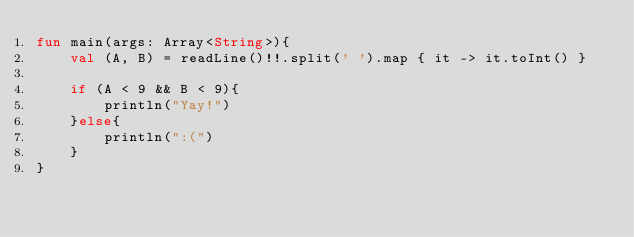Convert code to text. <code><loc_0><loc_0><loc_500><loc_500><_Kotlin_>fun main(args: Array<String>){
    val (A, B) = readLine()!!.split(' ').map { it -> it.toInt() }

    if (A < 9 && B < 9){
        println("Yay!")
    }else{
        println(":(")
    }
}</code> 